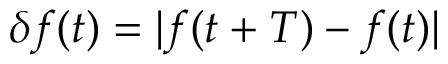<formula> <loc_0><loc_0><loc_500><loc_500>\delta f ( t ) = | f ( t + T ) - f ( t ) |</formula> 